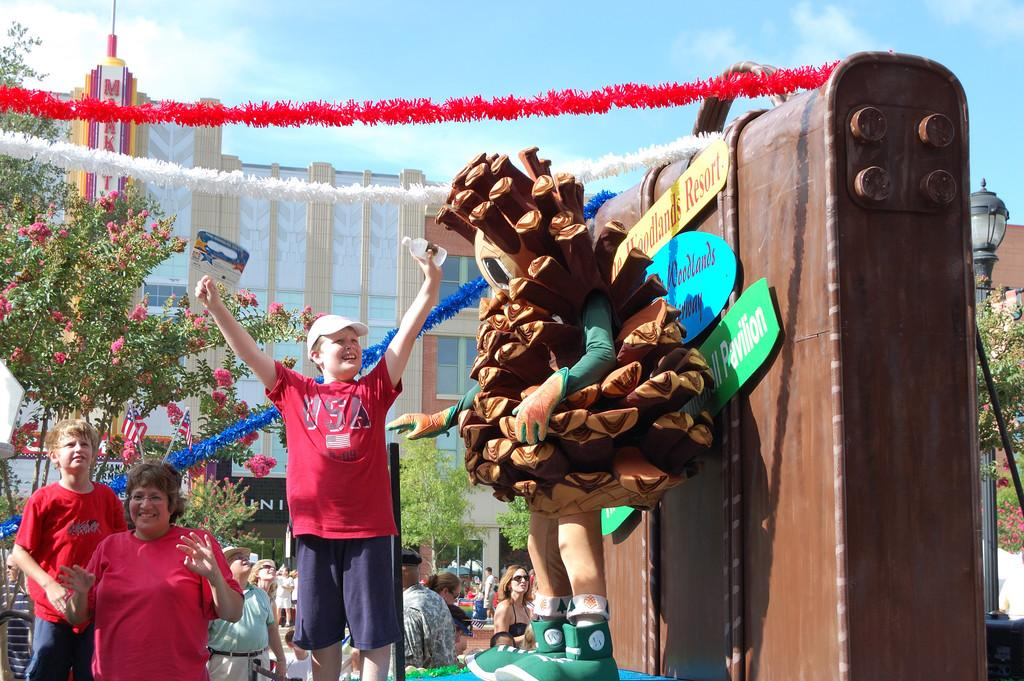What are the people in the image doing? The people in the image are standing on the road. What is in front of the people? There is a sculpture in front of the people. What is located behind the people? There is a building and trees behind the people. How many bees can be seen flying around the sculpture in the image? There are no bees visible in the image; the focus is on the people, sculpture, building, and trees. 